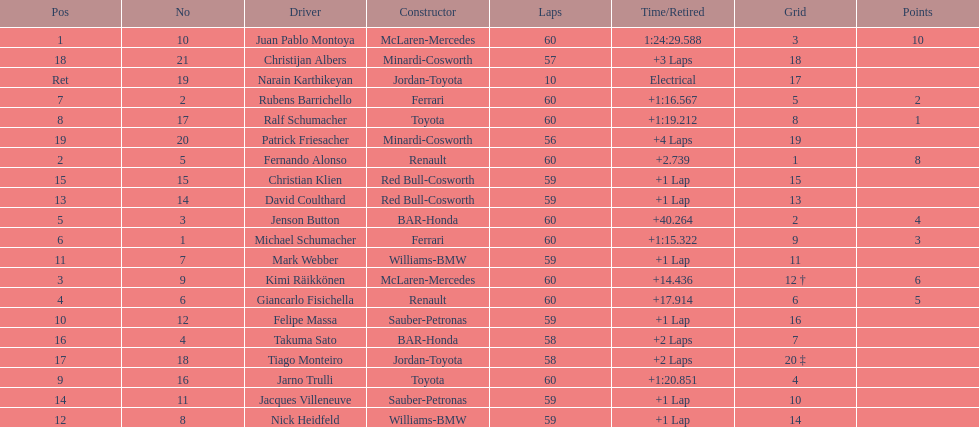Is there a points difference between the 9th position and 19th position on the list? No. 